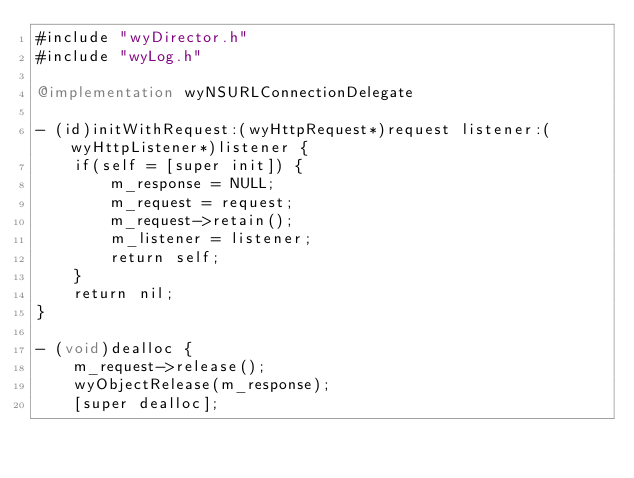Convert code to text. <code><loc_0><loc_0><loc_500><loc_500><_ObjectiveC_>#include "wyDirector.h"
#include "wyLog.h"

@implementation wyNSURLConnectionDelegate

- (id)initWithRequest:(wyHttpRequest*)request listener:(wyHttpListener*)listener {
    if(self = [super init]) {
        m_response = NULL;
        m_request = request;
        m_request->retain();
        m_listener = listener;
        return self;
    }
    return nil;
}

- (void)dealloc {
    m_request->release();
    wyObjectRelease(m_response);
    [super dealloc];</code> 